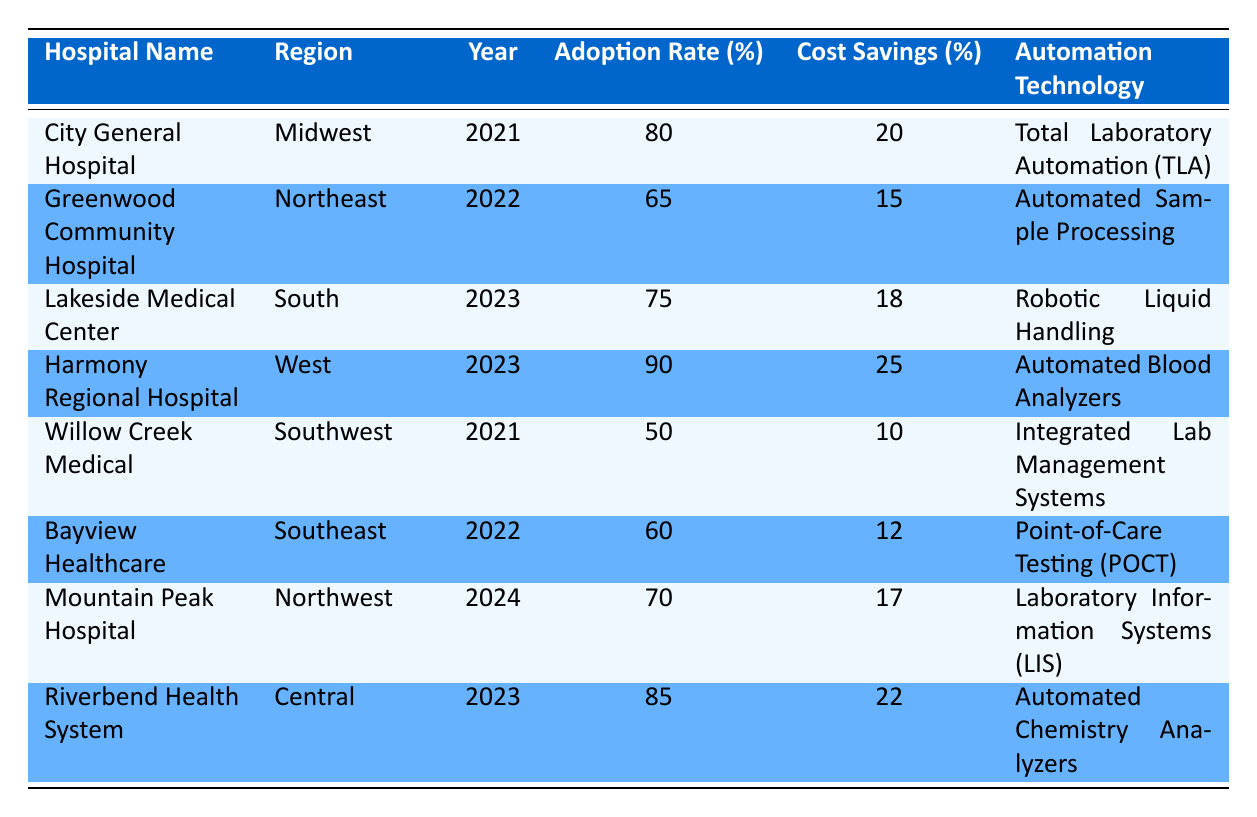What is the adoption rate of Harmony Regional Hospital? According to the table, Harmony Regional Hospital's adoption rate is listed under the "Adoption Rate (%)" column for the year 2023, which shows 90%.
Answer: 90% Which hospital has the highest cost savings percentage? By examining the "Cost Savings (%)" column, Harmony Regional Hospital shows the highest cost savings percentage at 25%.
Answer: 25% What is the average adoption rate of laboratory automation technologies across all listed hospitals? To find the average, sum all adoption rates: 80 (City General) + 65 (Greenwood) + 75 (Lakeside) + 90 (Harmony) + 50 (Willow Creek) + 60 (Bayview) + 70 (Mountain Peak) + 85 (Riverbend) = 675; there are 8 hospitals, so the average is 675 / 8 = 84.375%.
Answer: 84.375% Did any hospital in the Southeast region have an adoption rate greater than 60%? Looking at the Southeast region, Bayview Healthcare's adoption rate is 60%, which is not greater than 60%. Thus, the answer is no.
Answer: No Which automation technology has the lowest adoption rate? By analyzing the "Adoption Rate (%)" column, Integrated Lab Management Systems at Willow Creek Medical has the lowest rate at 50%.
Answer: 50% Are hospitals in the West region generally adopting automation technologies more than hospitals in the South region? Harmony Regional Hospital in the West has an adoption rate of 90%, whereas Lakeside Medical Center in the South has a rate of 75%. Since 90% is greater than 75%, the answer is yes.
Answer: Yes What is the total cost savings percentage for hospitals that adopted Automated technologies? The hospitals that adopted automated technologies are: Total Laboratory Automation (20%), Automated Sample Processing (15%), Robotic Liquid Handling (18%), Automated Blood Analyzers (25%), Automated Chemistry Analyzers (22%). Summing these gives 20 + 15 + 18 + 25 + 22 = 100%.
Answer: 100% Which hospital's adoption rate is closest to the median value of all adoption rates? The sorted adoption rates are: 50, 60, 65, 70, 75, 80, 85, and 90. The median is (70 + 75) / 2 = 72.5. The hospital closest to this median is Mountain Peak Hospital with an adoption rate of 70%.
Answer: Mountain Peak Hospital Which region has the hospital with the highest error reduction percentage? By examining the "Error Reduction Percentage" column, Harmony Regional Hospital has the highest percentage at 35%. This hospital is located in the West region, therefore, the answer is the West region.
Answer: West 